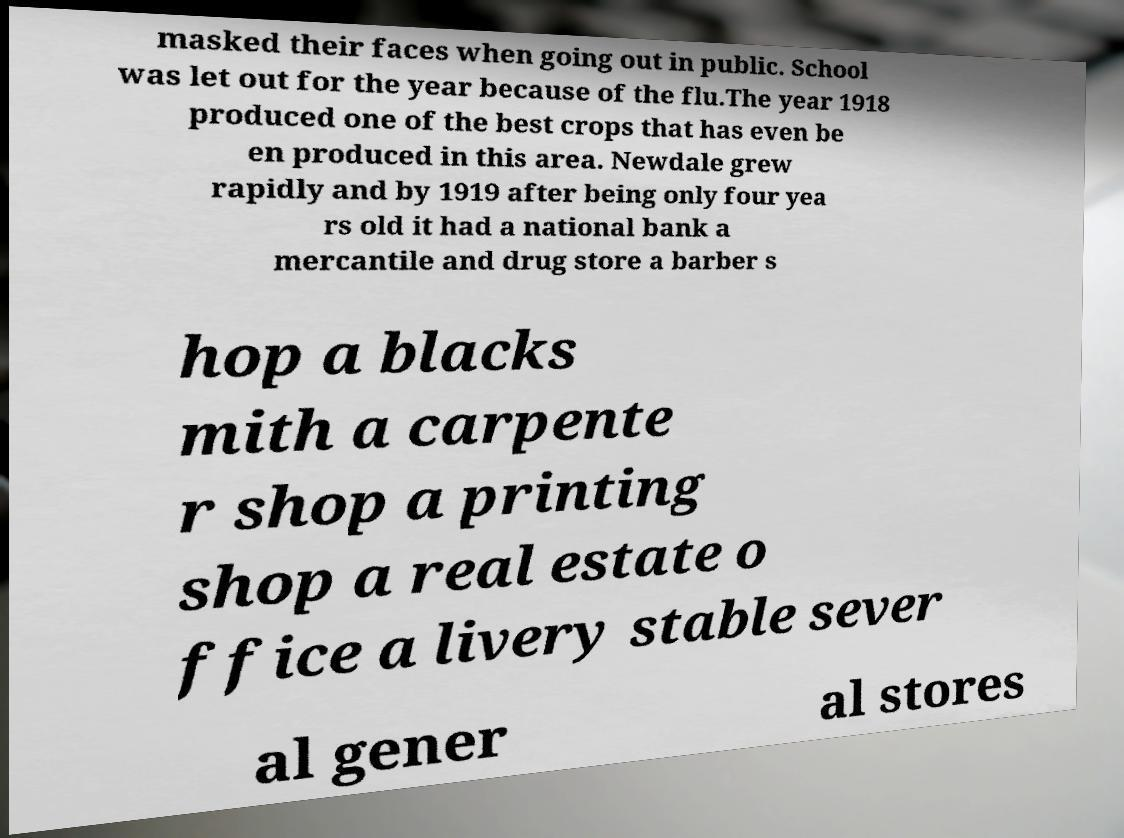Could you assist in decoding the text presented in this image and type it out clearly? masked their faces when going out in public. School was let out for the year because of the flu.The year 1918 produced one of the best crops that has even be en produced in this area. Newdale grew rapidly and by 1919 after being only four yea rs old it had a national bank a mercantile and drug store a barber s hop a blacks mith a carpente r shop a printing shop a real estate o ffice a livery stable sever al gener al stores 